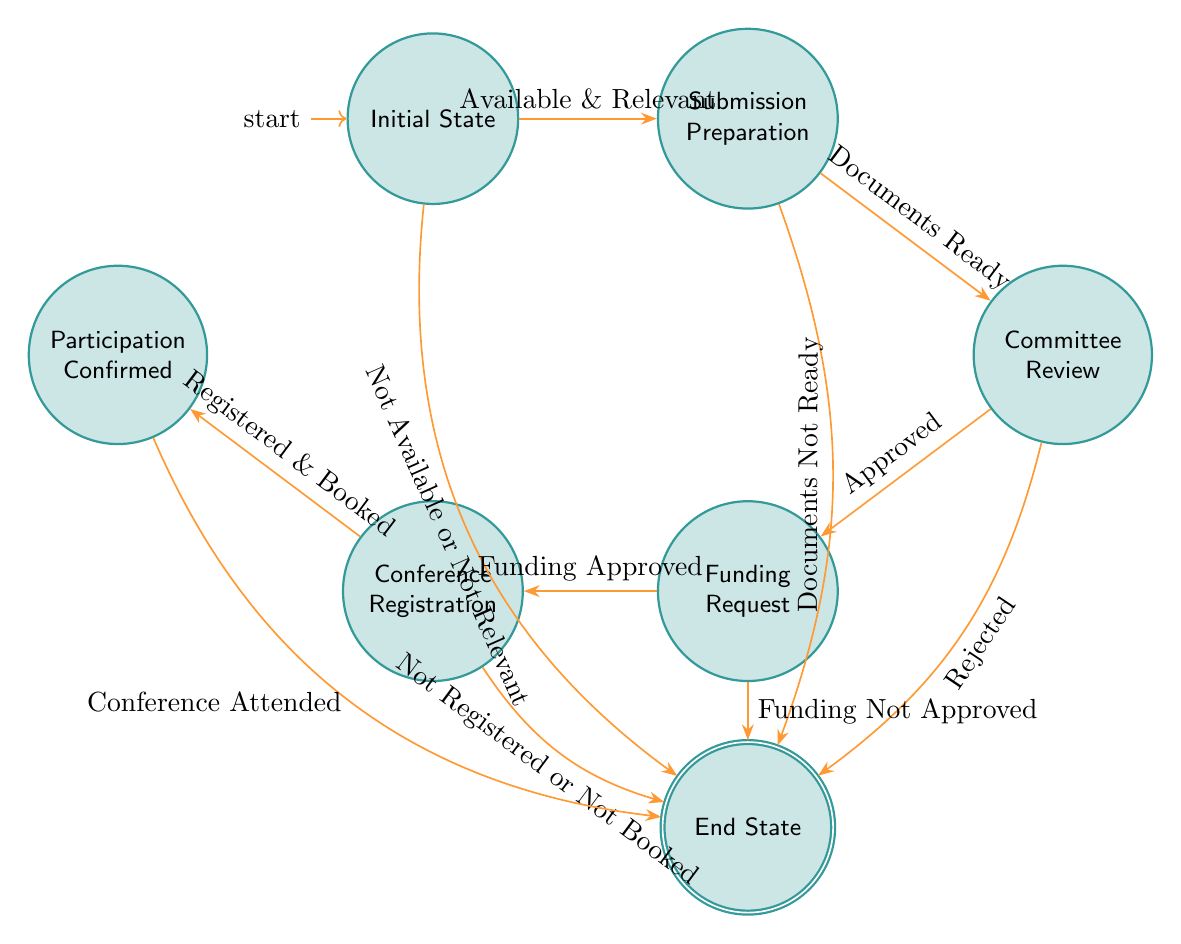What are the actions in the Initial State? The Initial State has two actions listed: "Check Availability" and "Assess Relevance." These actions are the starting point for the process of academic conference participation approval.
Answer: Check Availability, Assess Relevance How many transition paths lead from the Submission Preparation state? There are two transition paths leading from the Submission Preparation state: "Documents Ready" and "Documents Not Ready." These transitions indicate the possible outcomes based on the status of the documents.
Answer: 2 What happens if the documents are ready during Submission Preparation? If the documents are ready, the process transitions to the Committee Review state. This indicates the next step after preparing the necessary documentation for the conference.
Answer: Committee Review What is the consequence of the committee rejecting the submission? Should the committee reject the submission, the process will transition to the End State. This represents a conclusion where the participation is not approved.
Answer: End State What must be approved for the Funding Request to proceed? The transition from the Funding Request state to the Conference Registration state requires "Funding Approved." Without this approval, the process cannot continue to conference registration.
Answer: Funding Approved How many total nodes are there in the diagram? The diagram consists of six nodes: Initial State, Submission Preparation, Committee Review, Funding Request, Conference Registration, and Participation Confirmed, along with the End State. Each node represents a step in the approval hierarchy.
Answer: 7 If the conference registration is successful, what is the next state? After a successful conference registration, where one is "Registered and Booked," the next state is Participation Confirmed, indicating that the individual is set to attend the conference.
Answer: Participation Confirmed What occurs at the Participation Confirmed state? At the Participation Confirmed state, the action taken is to "Attend Conference," leading to a final step upon completion, transitioning to the End State once the conference is attended.
Answer: Attend Conference What leads to the End State from the Funding Request? The transition to the End State from the Funding Request occurs if "Funding Not Approved." This outcome halts the progress towards attendance at the conference.
Answer: Funding Not Approved 